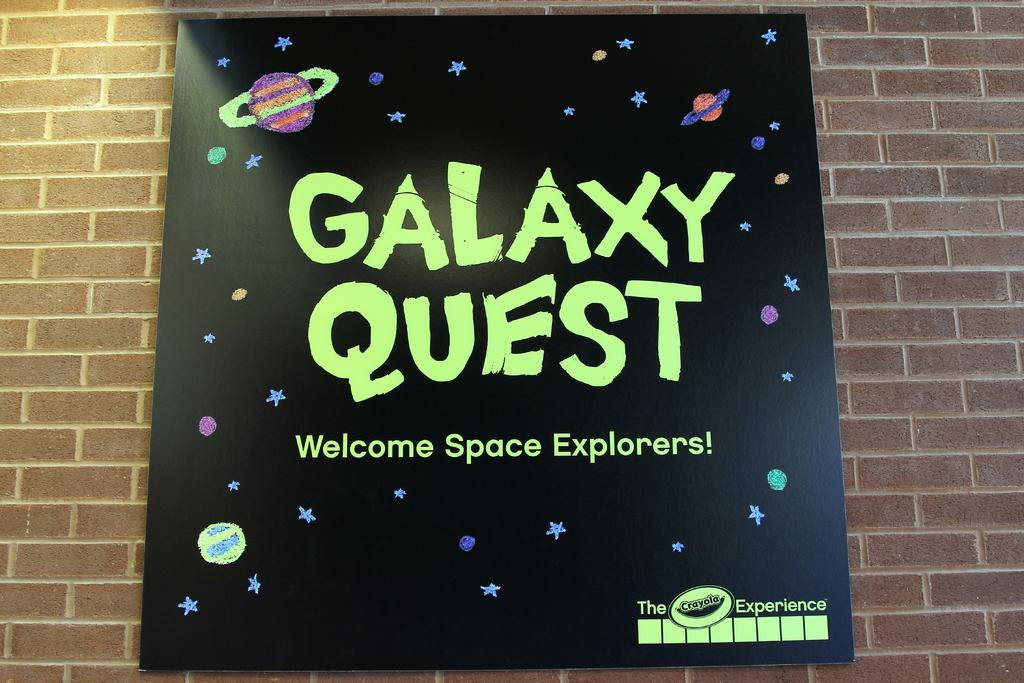<image>
Provide a brief description of the given image. A sign welcomes space explorers to Galaxy Quest. 